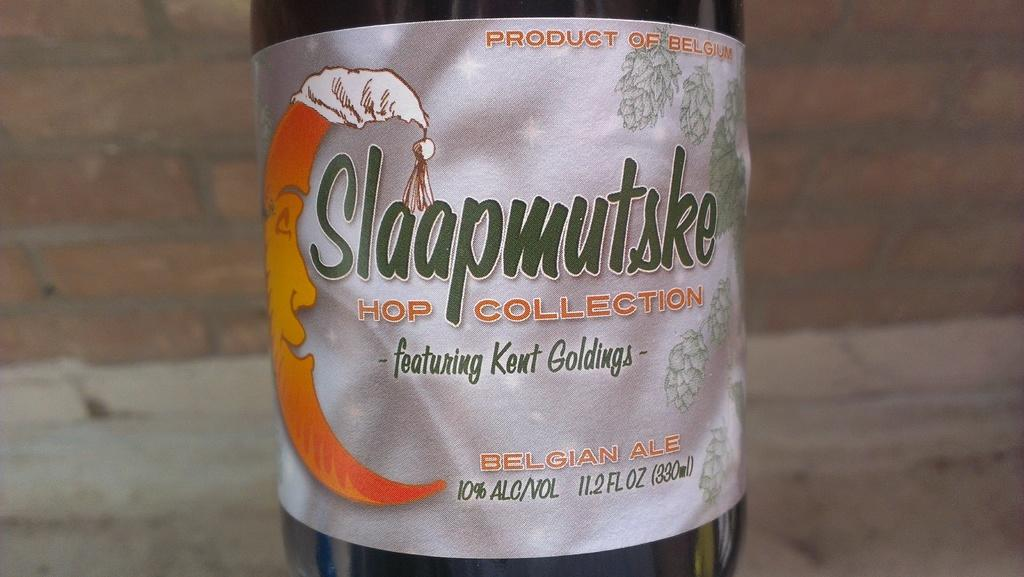<image>
Provide a brief description of the given image. A bottle of beer named Slaapmutske that features Kent Goldings. 